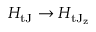Convert formula to latex. <formula><loc_0><loc_0><loc_500><loc_500>H _ { t J } \rightarrow H _ { t J _ { z } }</formula> 